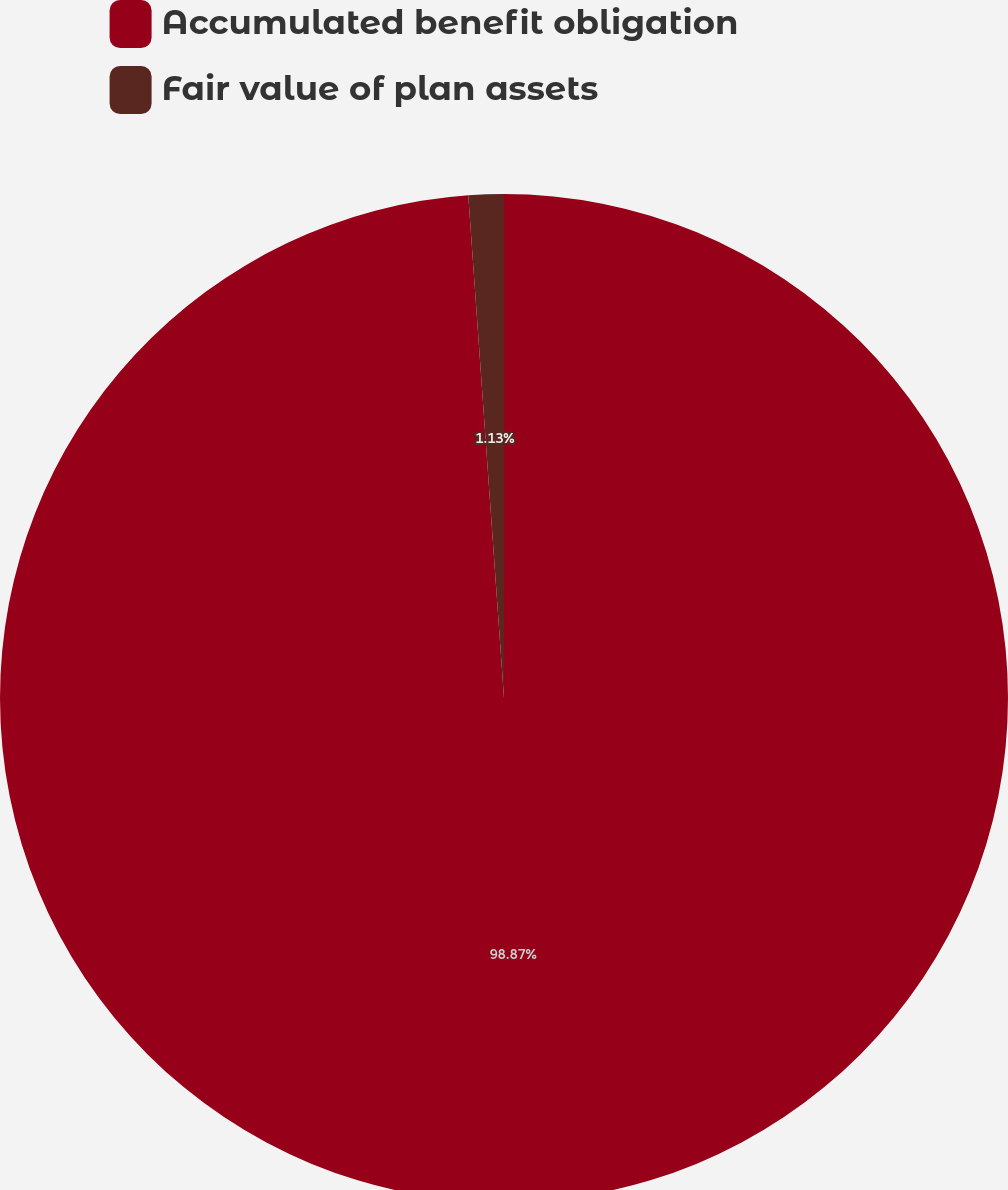Convert chart to OTSL. <chart><loc_0><loc_0><loc_500><loc_500><pie_chart><fcel>Accumulated benefit obligation<fcel>Fair value of plan assets<nl><fcel>98.87%<fcel>1.13%<nl></chart> 